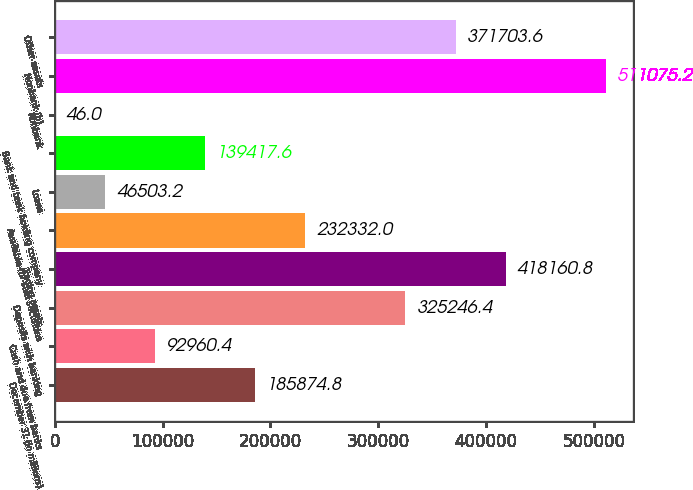Convert chart to OTSL. <chart><loc_0><loc_0><loc_500><loc_500><bar_chart><fcel>December 31 (in millions)<fcel>Cash and due from banks<fcel>Deposits with banking<fcel>Trading assets<fcel>Available-for-sale securities<fcel>Loans<fcel>Bank and bank holding company<fcel>Nonbank<fcel>Nonbank (b)<fcel>Other assets<nl><fcel>185875<fcel>92960.4<fcel>325246<fcel>418161<fcel>232332<fcel>46503.2<fcel>139418<fcel>46<fcel>511075<fcel>371704<nl></chart> 